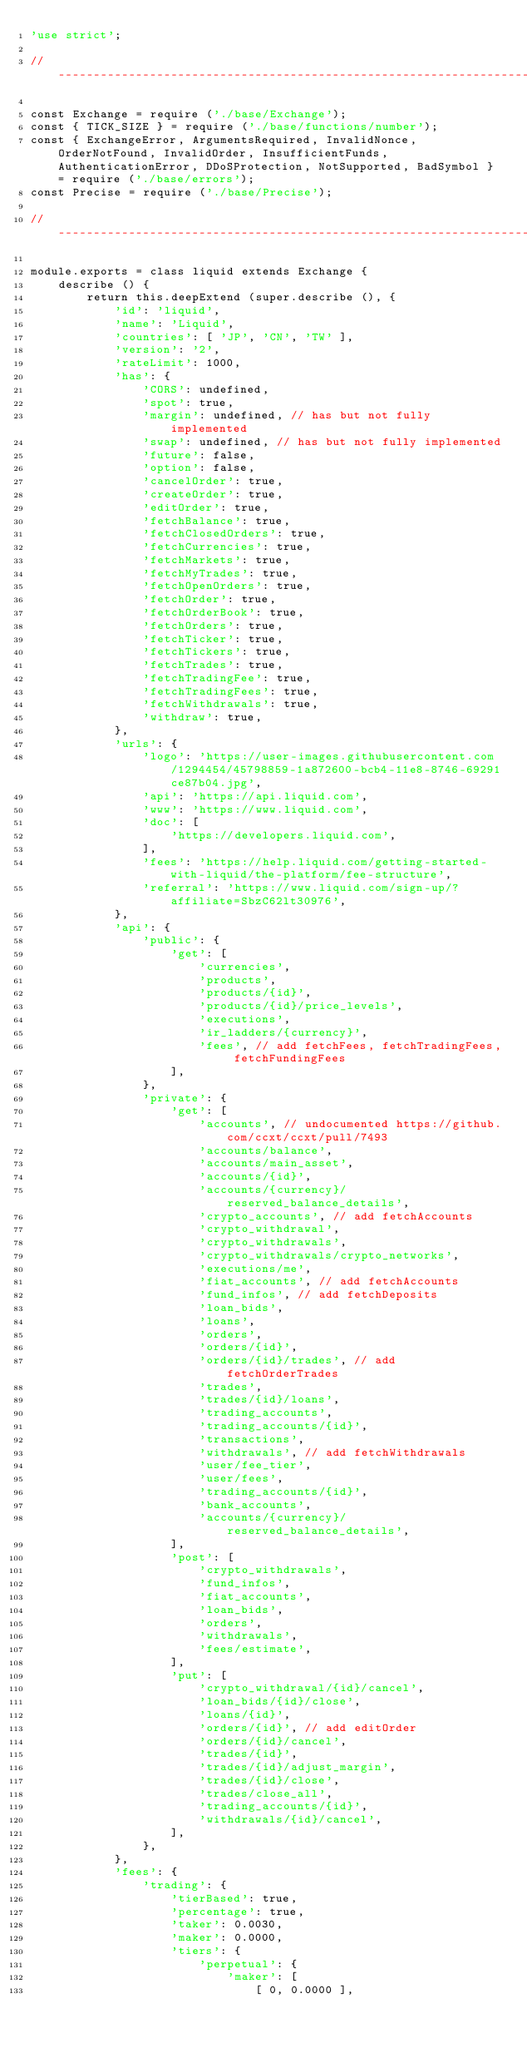<code> <loc_0><loc_0><loc_500><loc_500><_JavaScript_>'use strict';

//  ---------------------------------------------------------------------------

const Exchange = require ('./base/Exchange');
const { TICK_SIZE } = require ('./base/functions/number');
const { ExchangeError, ArgumentsRequired, InvalidNonce, OrderNotFound, InvalidOrder, InsufficientFunds, AuthenticationError, DDoSProtection, NotSupported, BadSymbol } = require ('./base/errors');
const Precise = require ('./base/Precise');

//  ---------------------------------------------------------------------------

module.exports = class liquid extends Exchange {
    describe () {
        return this.deepExtend (super.describe (), {
            'id': 'liquid',
            'name': 'Liquid',
            'countries': [ 'JP', 'CN', 'TW' ],
            'version': '2',
            'rateLimit': 1000,
            'has': {
                'CORS': undefined,
                'spot': true,
                'margin': undefined, // has but not fully implemented
                'swap': undefined, // has but not fully implemented
                'future': false,
                'option': false,
                'cancelOrder': true,
                'createOrder': true,
                'editOrder': true,
                'fetchBalance': true,
                'fetchClosedOrders': true,
                'fetchCurrencies': true,
                'fetchMarkets': true,
                'fetchMyTrades': true,
                'fetchOpenOrders': true,
                'fetchOrder': true,
                'fetchOrderBook': true,
                'fetchOrders': true,
                'fetchTicker': true,
                'fetchTickers': true,
                'fetchTrades': true,
                'fetchTradingFee': true,
                'fetchTradingFees': true,
                'fetchWithdrawals': true,
                'withdraw': true,
            },
            'urls': {
                'logo': 'https://user-images.githubusercontent.com/1294454/45798859-1a872600-bcb4-11e8-8746-69291ce87b04.jpg',
                'api': 'https://api.liquid.com',
                'www': 'https://www.liquid.com',
                'doc': [
                    'https://developers.liquid.com',
                ],
                'fees': 'https://help.liquid.com/getting-started-with-liquid/the-platform/fee-structure',
                'referral': 'https://www.liquid.com/sign-up/?affiliate=SbzC62lt30976',
            },
            'api': {
                'public': {
                    'get': [
                        'currencies',
                        'products',
                        'products/{id}',
                        'products/{id}/price_levels',
                        'executions',
                        'ir_ladders/{currency}',
                        'fees', // add fetchFees, fetchTradingFees, fetchFundingFees
                    ],
                },
                'private': {
                    'get': [
                        'accounts', // undocumented https://github.com/ccxt/ccxt/pull/7493
                        'accounts/balance',
                        'accounts/main_asset',
                        'accounts/{id}',
                        'accounts/{currency}/reserved_balance_details',
                        'crypto_accounts', // add fetchAccounts
                        'crypto_withdrawal',
                        'crypto_withdrawals',
                        'crypto_withdrawals/crypto_networks',
                        'executions/me',
                        'fiat_accounts', // add fetchAccounts
                        'fund_infos', // add fetchDeposits
                        'loan_bids',
                        'loans',
                        'orders',
                        'orders/{id}',
                        'orders/{id}/trades', // add fetchOrderTrades
                        'trades',
                        'trades/{id}/loans',
                        'trading_accounts',
                        'trading_accounts/{id}',
                        'transactions',
                        'withdrawals', // add fetchWithdrawals
                        'user/fee_tier',
                        'user/fees',
                        'trading_accounts/{id}',
                        'bank_accounts',
                        'accounts/{currency}/reserved_balance_details',
                    ],
                    'post': [
                        'crypto_withdrawals',
                        'fund_infos',
                        'fiat_accounts',
                        'loan_bids',
                        'orders',
                        'withdrawals',
                        'fees/estimate',
                    ],
                    'put': [
                        'crypto_withdrawal/{id}/cancel',
                        'loan_bids/{id}/close',
                        'loans/{id}',
                        'orders/{id}', // add editOrder
                        'orders/{id}/cancel',
                        'trades/{id}',
                        'trades/{id}/adjust_margin',
                        'trades/{id}/close',
                        'trades/close_all',
                        'trading_accounts/{id}',
                        'withdrawals/{id}/cancel',
                    ],
                },
            },
            'fees': {
                'trading': {
                    'tierBased': true,
                    'percentage': true,
                    'taker': 0.0030,
                    'maker': 0.0000,
                    'tiers': {
                        'perpetual': {
                            'maker': [
                                [ 0, 0.0000 ],</code> 